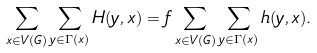Convert formula to latex. <formula><loc_0><loc_0><loc_500><loc_500>\sum _ { x \in V ( G ) } \sum _ { y \in \Gamma \left ( x \right ) } H ( y , x ) = f \sum _ { x \in V ( G ) } \sum _ { y \in \Gamma \left ( x \right ) } h ( y , x ) .</formula> 